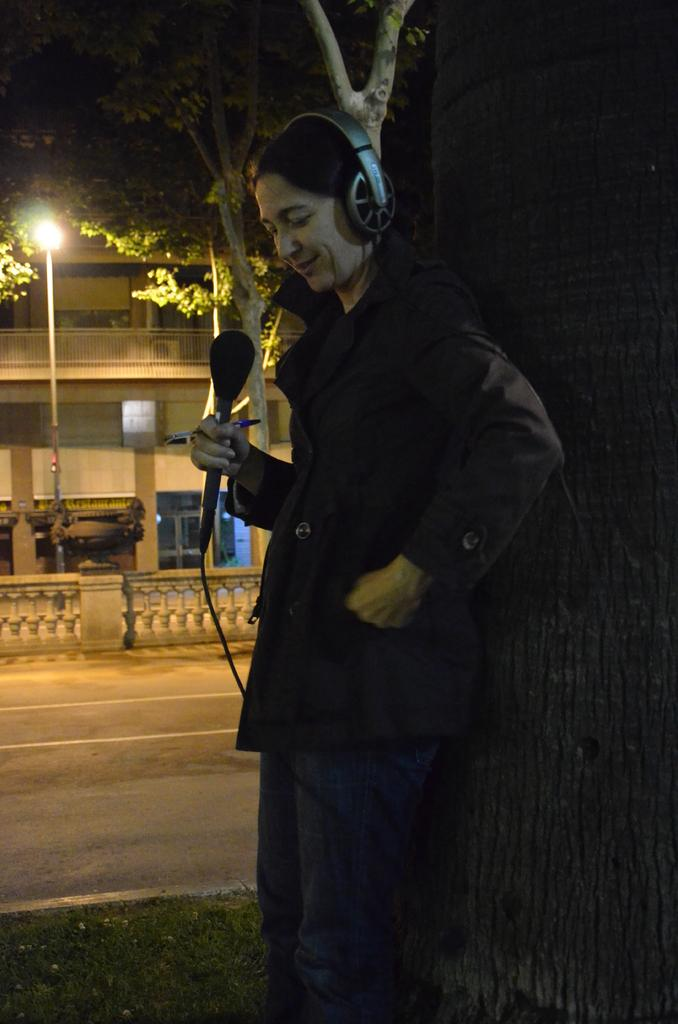Who is the main subject in the image? There is a woman in the image. What is the woman holding in the image? The woman is holding a microphone. What is the woman's expression in the image? The woman is smiling. What type of natural environment is visible in the image? There is grass in the image. What type of man-made structure is visible in the image? There is a building in the image. What other objects can be seen in the image? There is a road, a pole, a light, and trees in the image. What is the price of the frogs in the image? There are no frogs present in the image, so it is not possible to determine their price. 